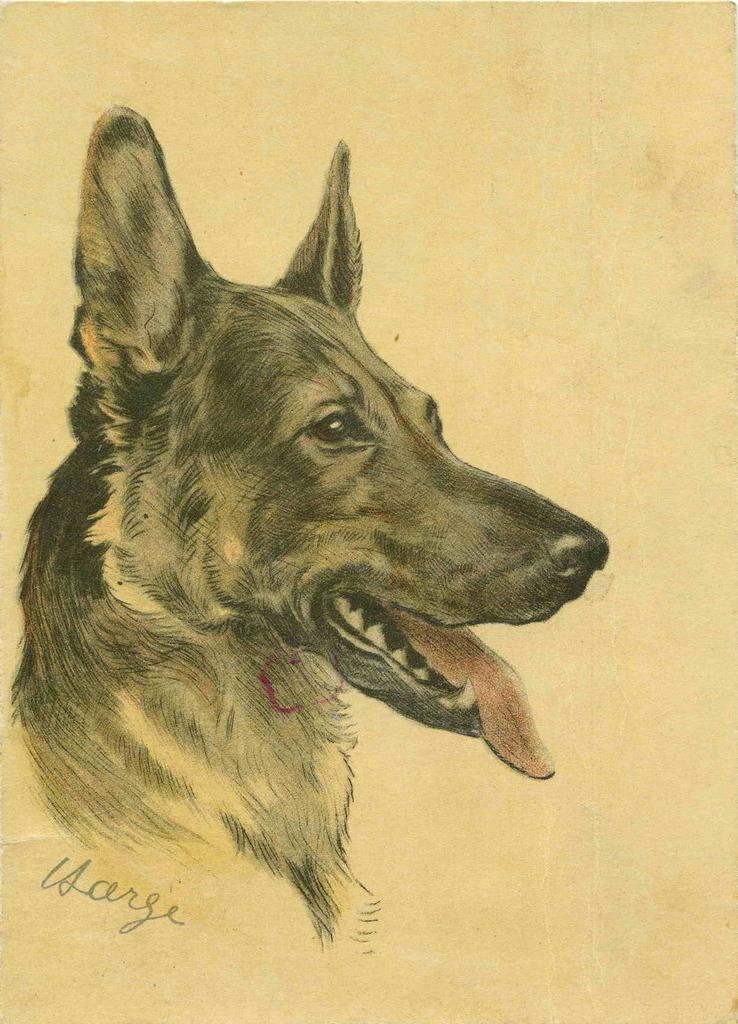What type of artwork is depicted in the image? The image is a drawing. What animal is featured in the drawing? There is a dog in the drawing. What type of curtain is hanging in the background of the drawing? There is no curtain present in the drawing; it only features a dog. What type of breakfast is being served to the dog in the drawing? There is no breakfast depicted in the drawing; it only features a dog. 